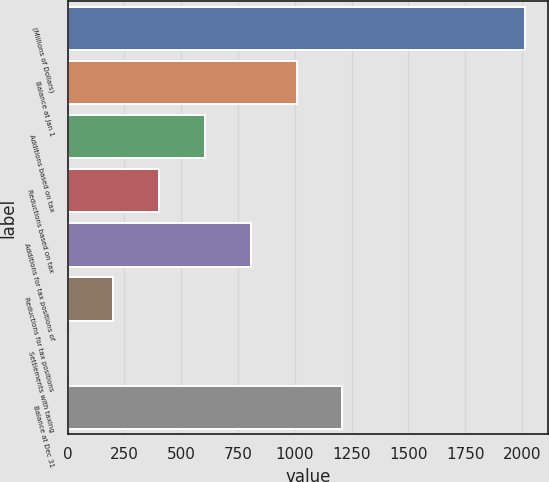Convert chart. <chart><loc_0><loc_0><loc_500><loc_500><bar_chart><fcel>(Millions of Dollars)<fcel>Balance at Jan 1<fcel>Additions based on tax<fcel>Reductions based on tax<fcel>Additions for tax positions of<fcel>Reductions for tax positions<fcel>Settlements with taxing<fcel>Balance at Dec 31<nl><fcel>2015<fcel>1007.65<fcel>604.71<fcel>403.24<fcel>806.18<fcel>201.77<fcel>0.3<fcel>1209.12<nl></chart> 